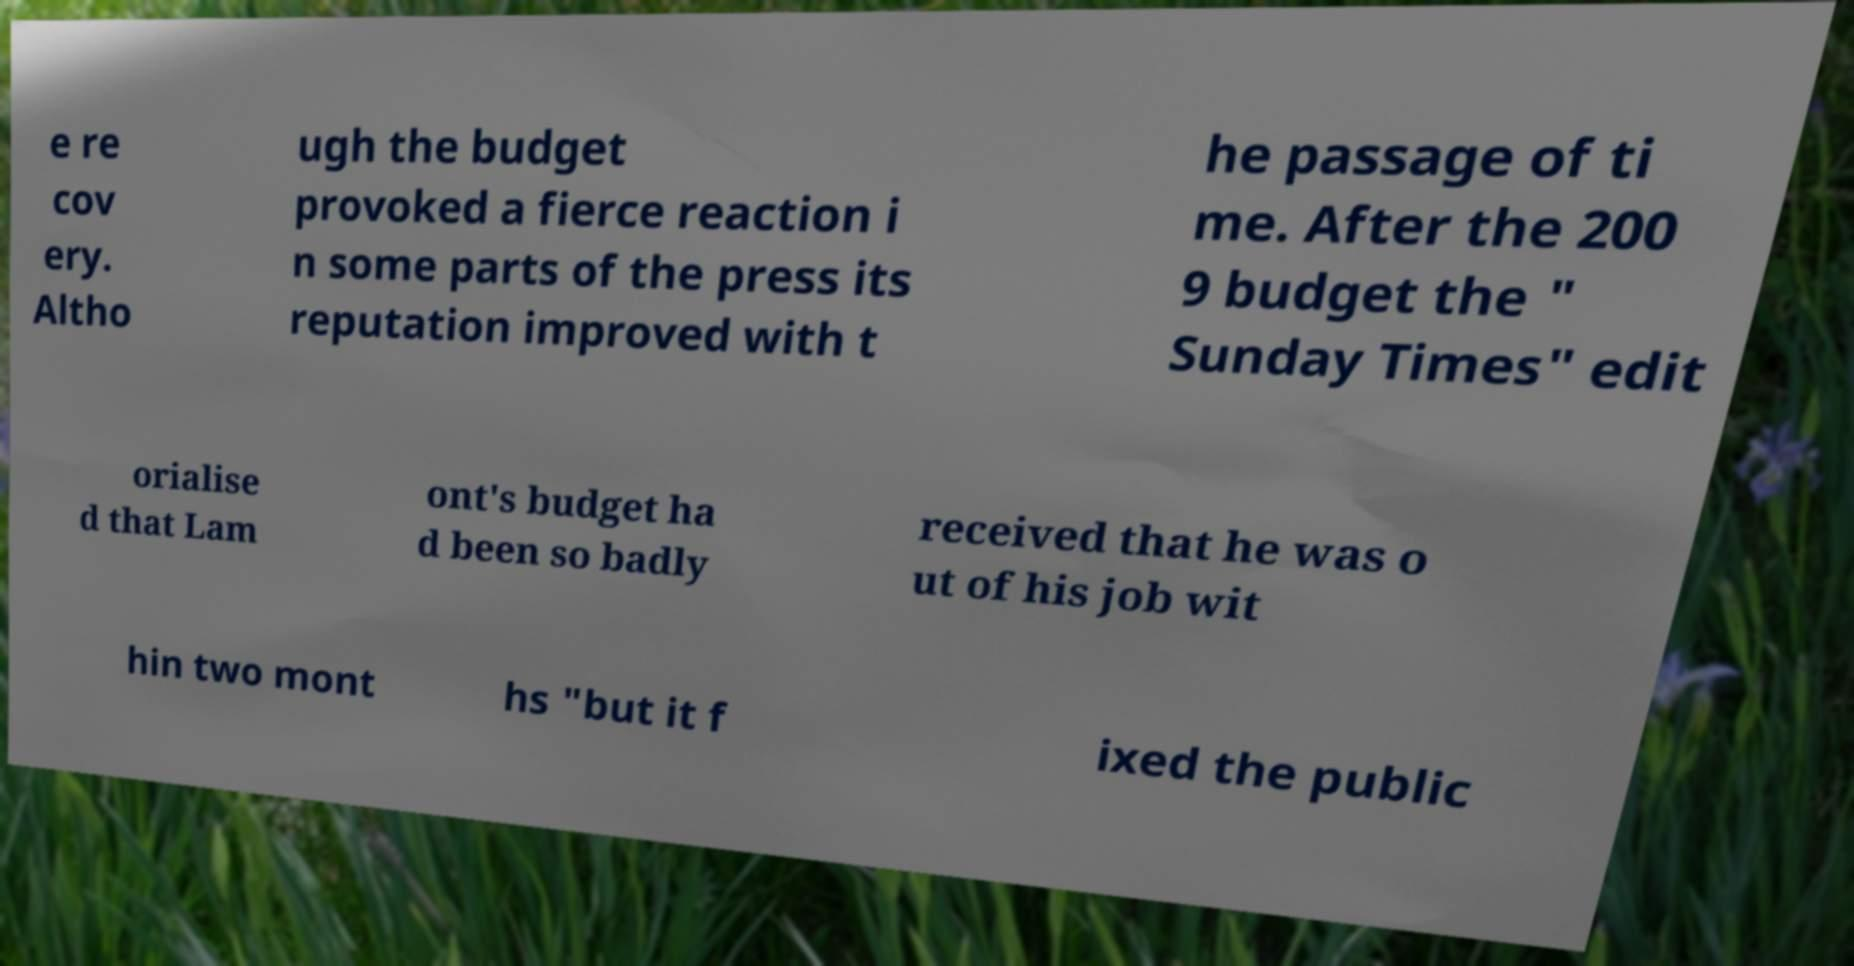What messages or text are displayed in this image? I need them in a readable, typed format. e re cov ery. Altho ugh the budget provoked a fierce reaction i n some parts of the press its reputation improved with t he passage of ti me. After the 200 9 budget the " Sunday Times" edit orialise d that Lam ont's budget ha d been so badly received that he was o ut of his job wit hin two mont hs "but it f ixed the public 